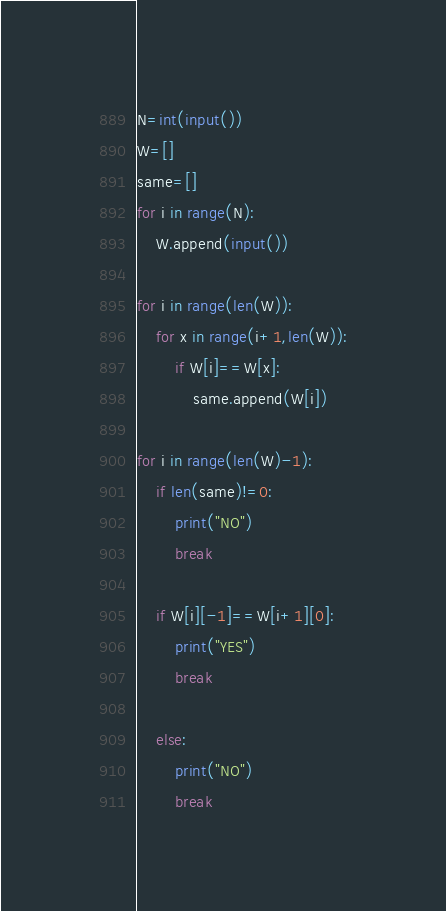<code> <loc_0><loc_0><loc_500><loc_500><_Python_>N=int(input())
W=[]
same=[]
for i in range(N):
    W.append(input())

for i in range(len(W)):
    for x in range(i+1,len(W)):
        if W[i]==W[x]:
            same.append(W[i])
  
for i in range(len(W)-1):
    if len(same)!=0:
        print("NO")
        break
    
    if W[i][-1]==W[i+1][0]:
        print("YES")
        break
        
    else:
        print("NO")
        break
</code> 